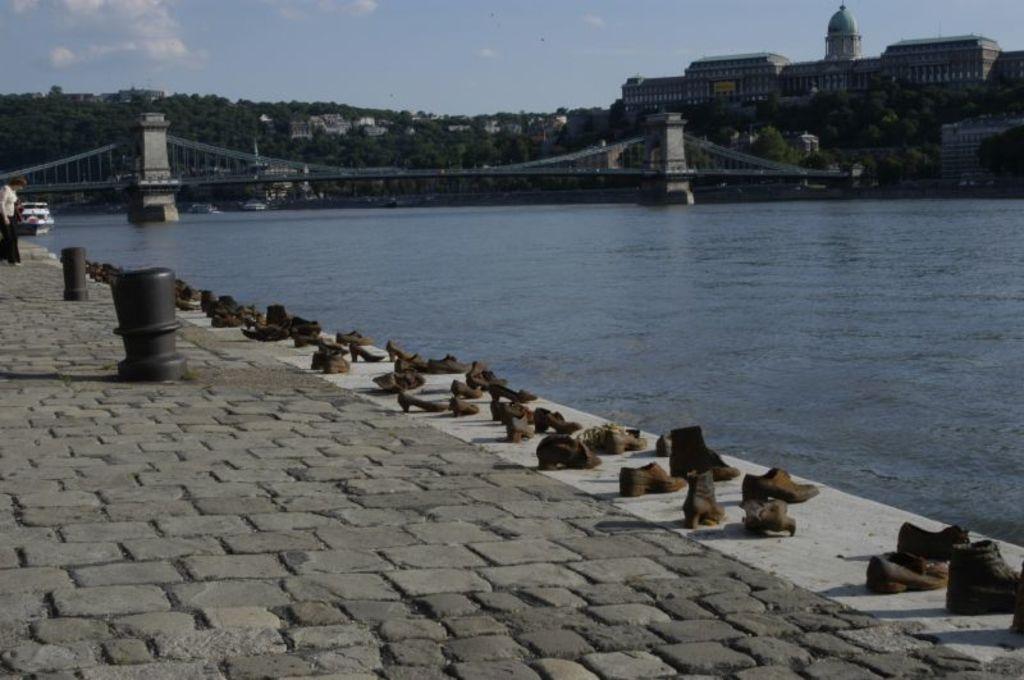Describe this image in one or two sentences. In this image we can see some sandals and boots on the pathway. On the backside we can see a water body and a bridge. We can also see a building with windows, some trees and the sky which looks cloudy. 